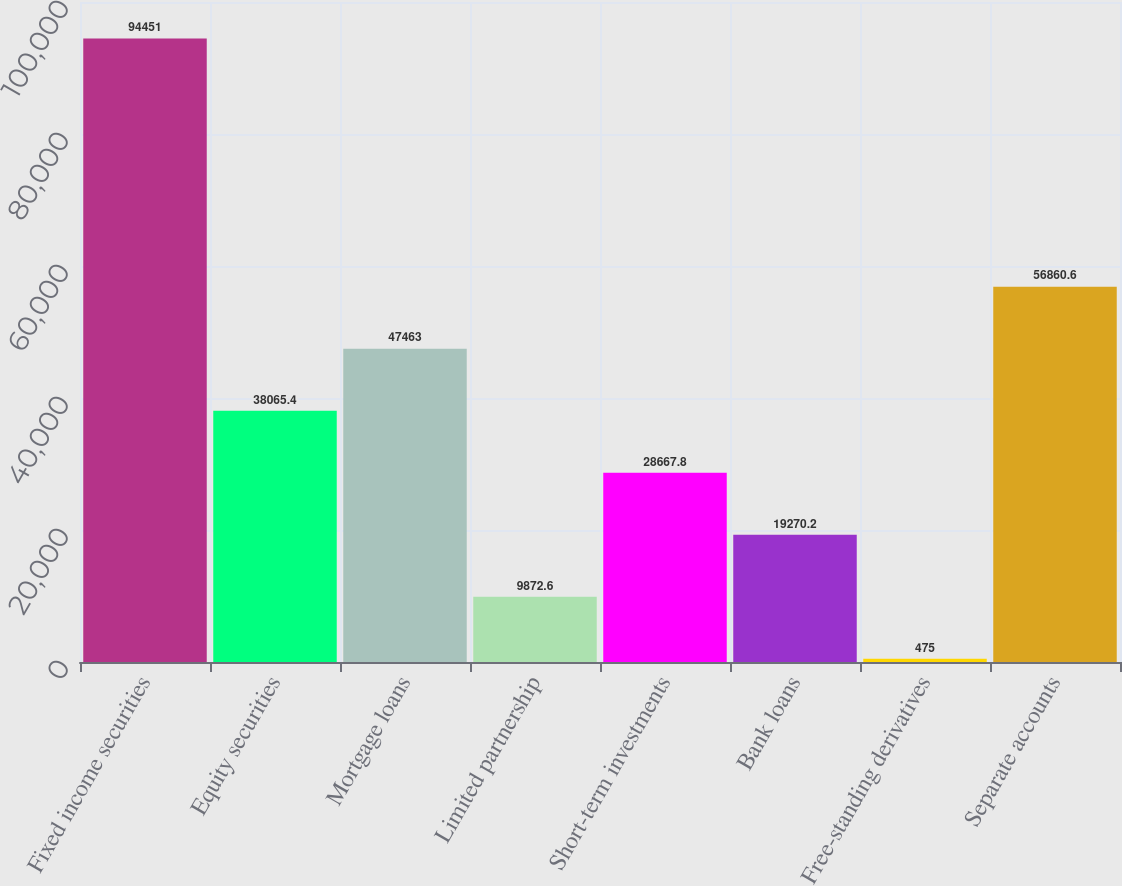Convert chart. <chart><loc_0><loc_0><loc_500><loc_500><bar_chart><fcel>Fixed income securities<fcel>Equity securities<fcel>Mortgage loans<fcel>Limited partnership<fcel>Short-term investments<fcel>Bank loans<fcel>Free-standing derivatives<fcel>Separate accounts<nl><fcel>94451<fcel>38065.4<fcel>47463<fcel>9872.6<fcel>28667.8<fcel>19270.2<fcel>475<fcel>56860.6<nl></chart> 